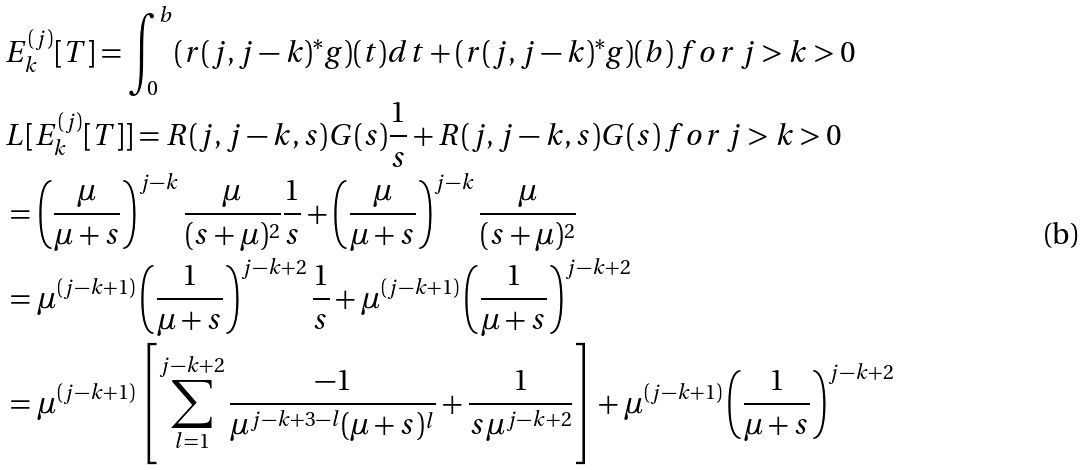<formula> <loc_0><loc_0><loc_500><loc_500>& E _ { k } ^ { ( j ) } [ T ] = \int _ { 0 } ^ { b } ( r ( j , j - k ) ^ { * } g ) ( t ) d t + ( r ( j , j - k ) ^ { * } g ) ( b ) \, f o r \, j > k > 0 \\ & L [ E _ { k } ^ { ( j ) } [ T ] ] = R ( j , j - k , s ) G ( s ) \frac { 1 } { s } + R ( j , j - k , s ) G ( s ) \, f o r \, j > k > 0 \\ & = \left ( \frac { \mu } { \mu + s } \right ) ^ { j - k } \frac { \mu } { ( s + \mu ) ^ { 2 } } \frac { 1 } { s } + \left ( \frac { \mu } { \mu + s } \right ) ^ { j - k } \frac { \mu } { ( s + \mu ) ^ { 2 } } \\ & = \mu ^ { ( j - k + 1 ) } \left ( \frac { 1 } { \mu + s } \right ) ^ { j - k + 2 } \frac { 1 } { s } + \mu ^ { ( j - k + 1 ) } \left ( \frac { 1 } { \mu + s } \right ) ^ { j - k + 2 } \\ & = \mu ^ { ( j - k + 1 ) } \left [ \sum _ { l = 1 } ^ { j - k + 2 } \frac { - 1 } { \mu ^ { j - k + 3 - l } ( \mu + s ) ^ { l } } + \frac { 1 } { s \mu ^ { j - k + 2 } } \right ] + \mu ^ { ( j - k + 1 ) } \left ( \frac { 1 } { \mu + s } \right ) ^ { j - k + 2 } \\</formula> 